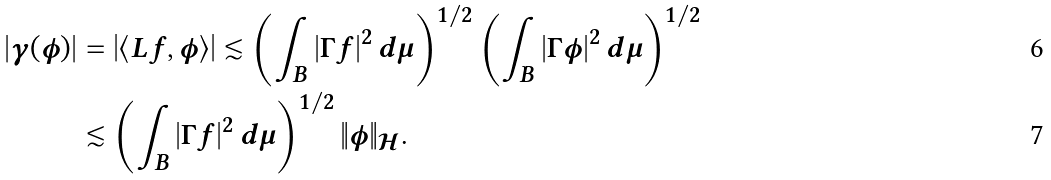Convert formula to latex. <formula><loc_0><loc_0><loc_500><loc_500>| \gamma ( \phi ) | & = \left | \langle L f , \phi \rangle \right | \lesssim \left ( \int _ { B } | \Gamma f | ^ { 2 } \, d \mu \right ) ^ { 1 / 2 } \left ( \int _ { B } | \Gamma \phi | ^ { 2 } \, d \mu \right ) ^ { 1 / 2 } \\ & \lesssim \left ( \int _ { B } | \Gamma f | ^ { 2 } \, d \mu \right ) ^ { 1 / 2 } \| \phi \| _ { \mathcal { H } } .</formula> 